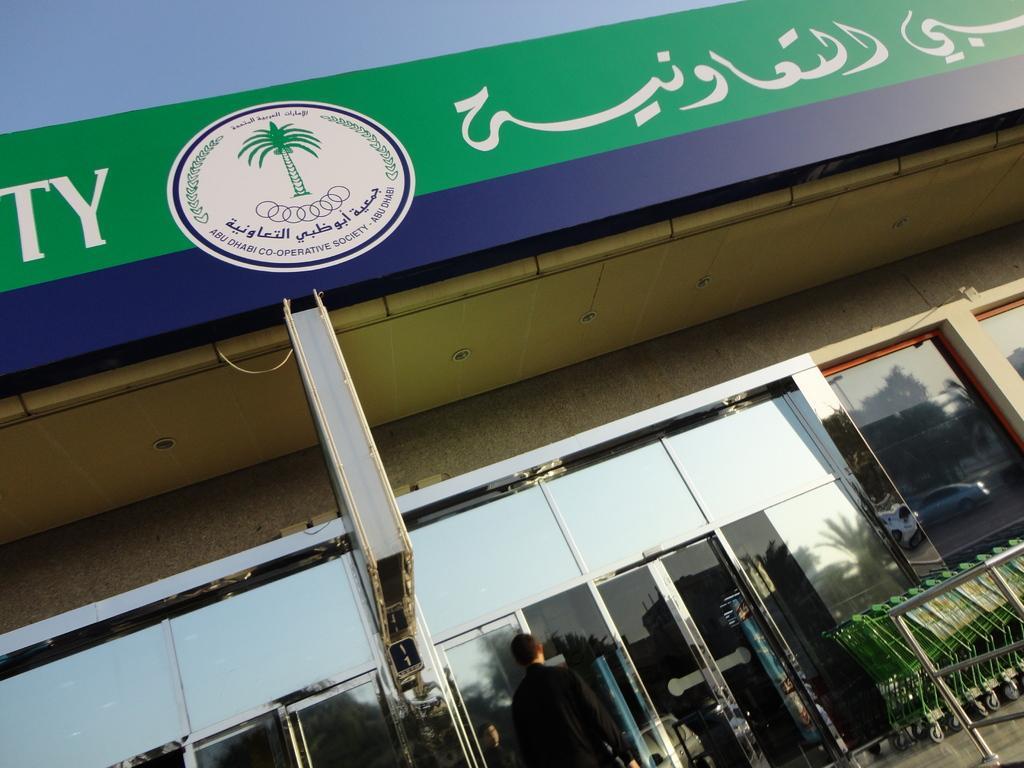Can you describe this image briefly? In this picture we can see a building with a logo and some text on it, here we can see a person, vehicles, trees and some objects. 